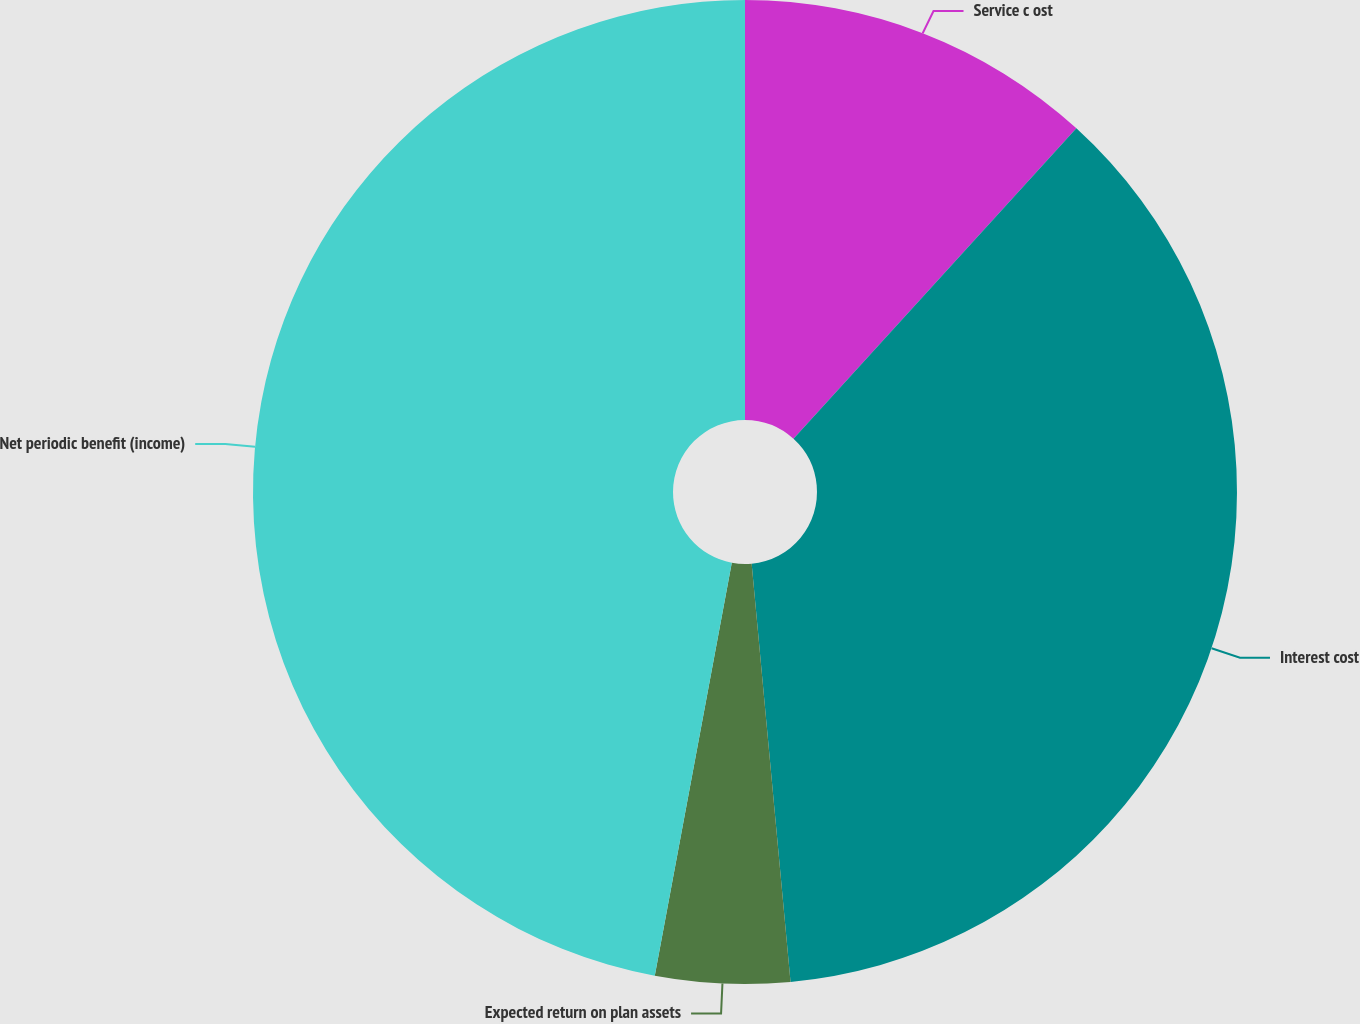Convert chart. <chart><loc_0><loc_0><loc_500><loc_500><pie_chart><fcel>Service c ost<fcel>Interest cost<fcel>Expected return on plan assets<fcel>Net periodic benefit (income)<nl><fcel>11.76%<fcel>36.76%<fcel>4.41%<fcel>47.06%<nl></chart> 